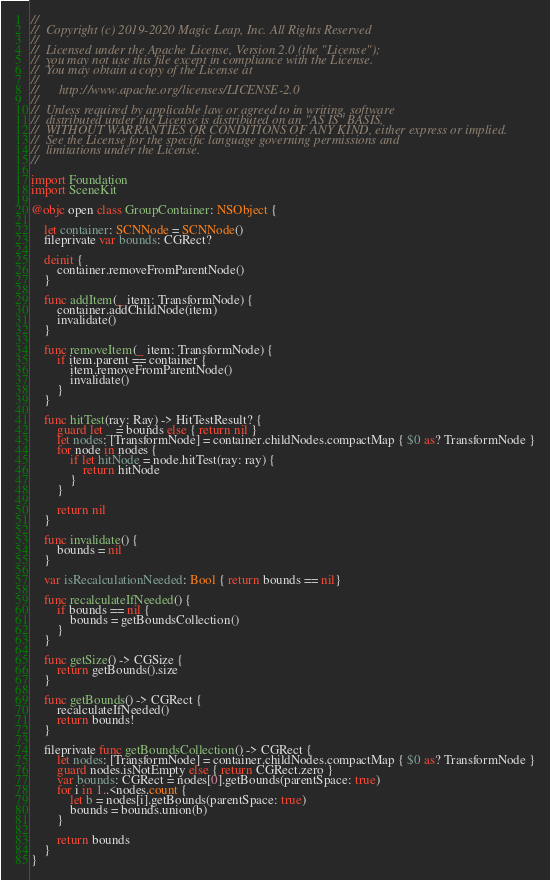Convert code to text. <code><loc_0><loc_0><loc_500><loc_500><_Swift_>//
//  Copyright (c) 2019-2020 Magic Leap, Inc. All Rights Reserved
//
//  Licensed under the Apache License, Version 2.0 (the "License");
//  you may not use this file except in compliance with the License.
//  You may obtain a copy of the License at
//
//      http://www.apache.org/licenses/LICENSE-2.0
//
//  Unless required by applicable law or agreed to in writing, software
//  distributed under the License is distributed on an "AS IS" BASIS,
//  WITHOUT WARRANTIES OR CONDITIONS OF ANY KIND, either express or implied.
//  See the License for the specific language governing permissions and
//  limitations under the License.
// 

import Foundation
import SceneKit

@objc open class GroupContainer: NSObject {

    let container: SCNNode = SCNNode()
    fileprivate var bounds: CGRect?

    deinit {
        container.removeFromParentNode()
    }

    func addItem(_ item: TransformNode) {
        container.addChildNode(item)
        invalidate()
    }

    func removeItem(_ item: TransformNode) {
        if item.parent == container {
            item.removeFromParentNode()
            invalidate()
        }
    }

    func hitTest(ray: Ray) -> HitTestResult? {
        guard let _ = bounds else { return nil }
        let nodes: [TransformNode] = container.childNodes.compactMap { $0 as? TransformNode }
        for node in nodes {
            if let hitNode = node.hitTest(ray: ray) {
                return hitNode
            }
        }

        return nil
    }

    func invalidate() {
        bounds = nil
    }

    var isRecalculationNeeded: Bool { return bounds == nil}

    func recalculateIfNeeded() {
        if bounds == nil {
            bounds = getBoundsCollection()
        }
    }

    func getSize() -> CGSize {
        return getBounds().size
    }

    func getBounds() -> CGRect {
        recalculateIfNeeded()
        return bounds!
    }

    fileprivate func getBoundsCollection() -> CGRect {
        let nodes: [TransformNode] = container.childNodes.compactMap { $0 as? TransformNode }
        guard nodes.isNotEmpty else { return CGRect.zero }
        var bounds: CGRect = nodes[0].getBounds(parentSpace: true)
        for i in 1..<nodes.count {
            let b = nodes[i].getBounds(parentSpace: true)
            bounds = bounds.union(b)
        }

        return bounds
    }
}
</code> 